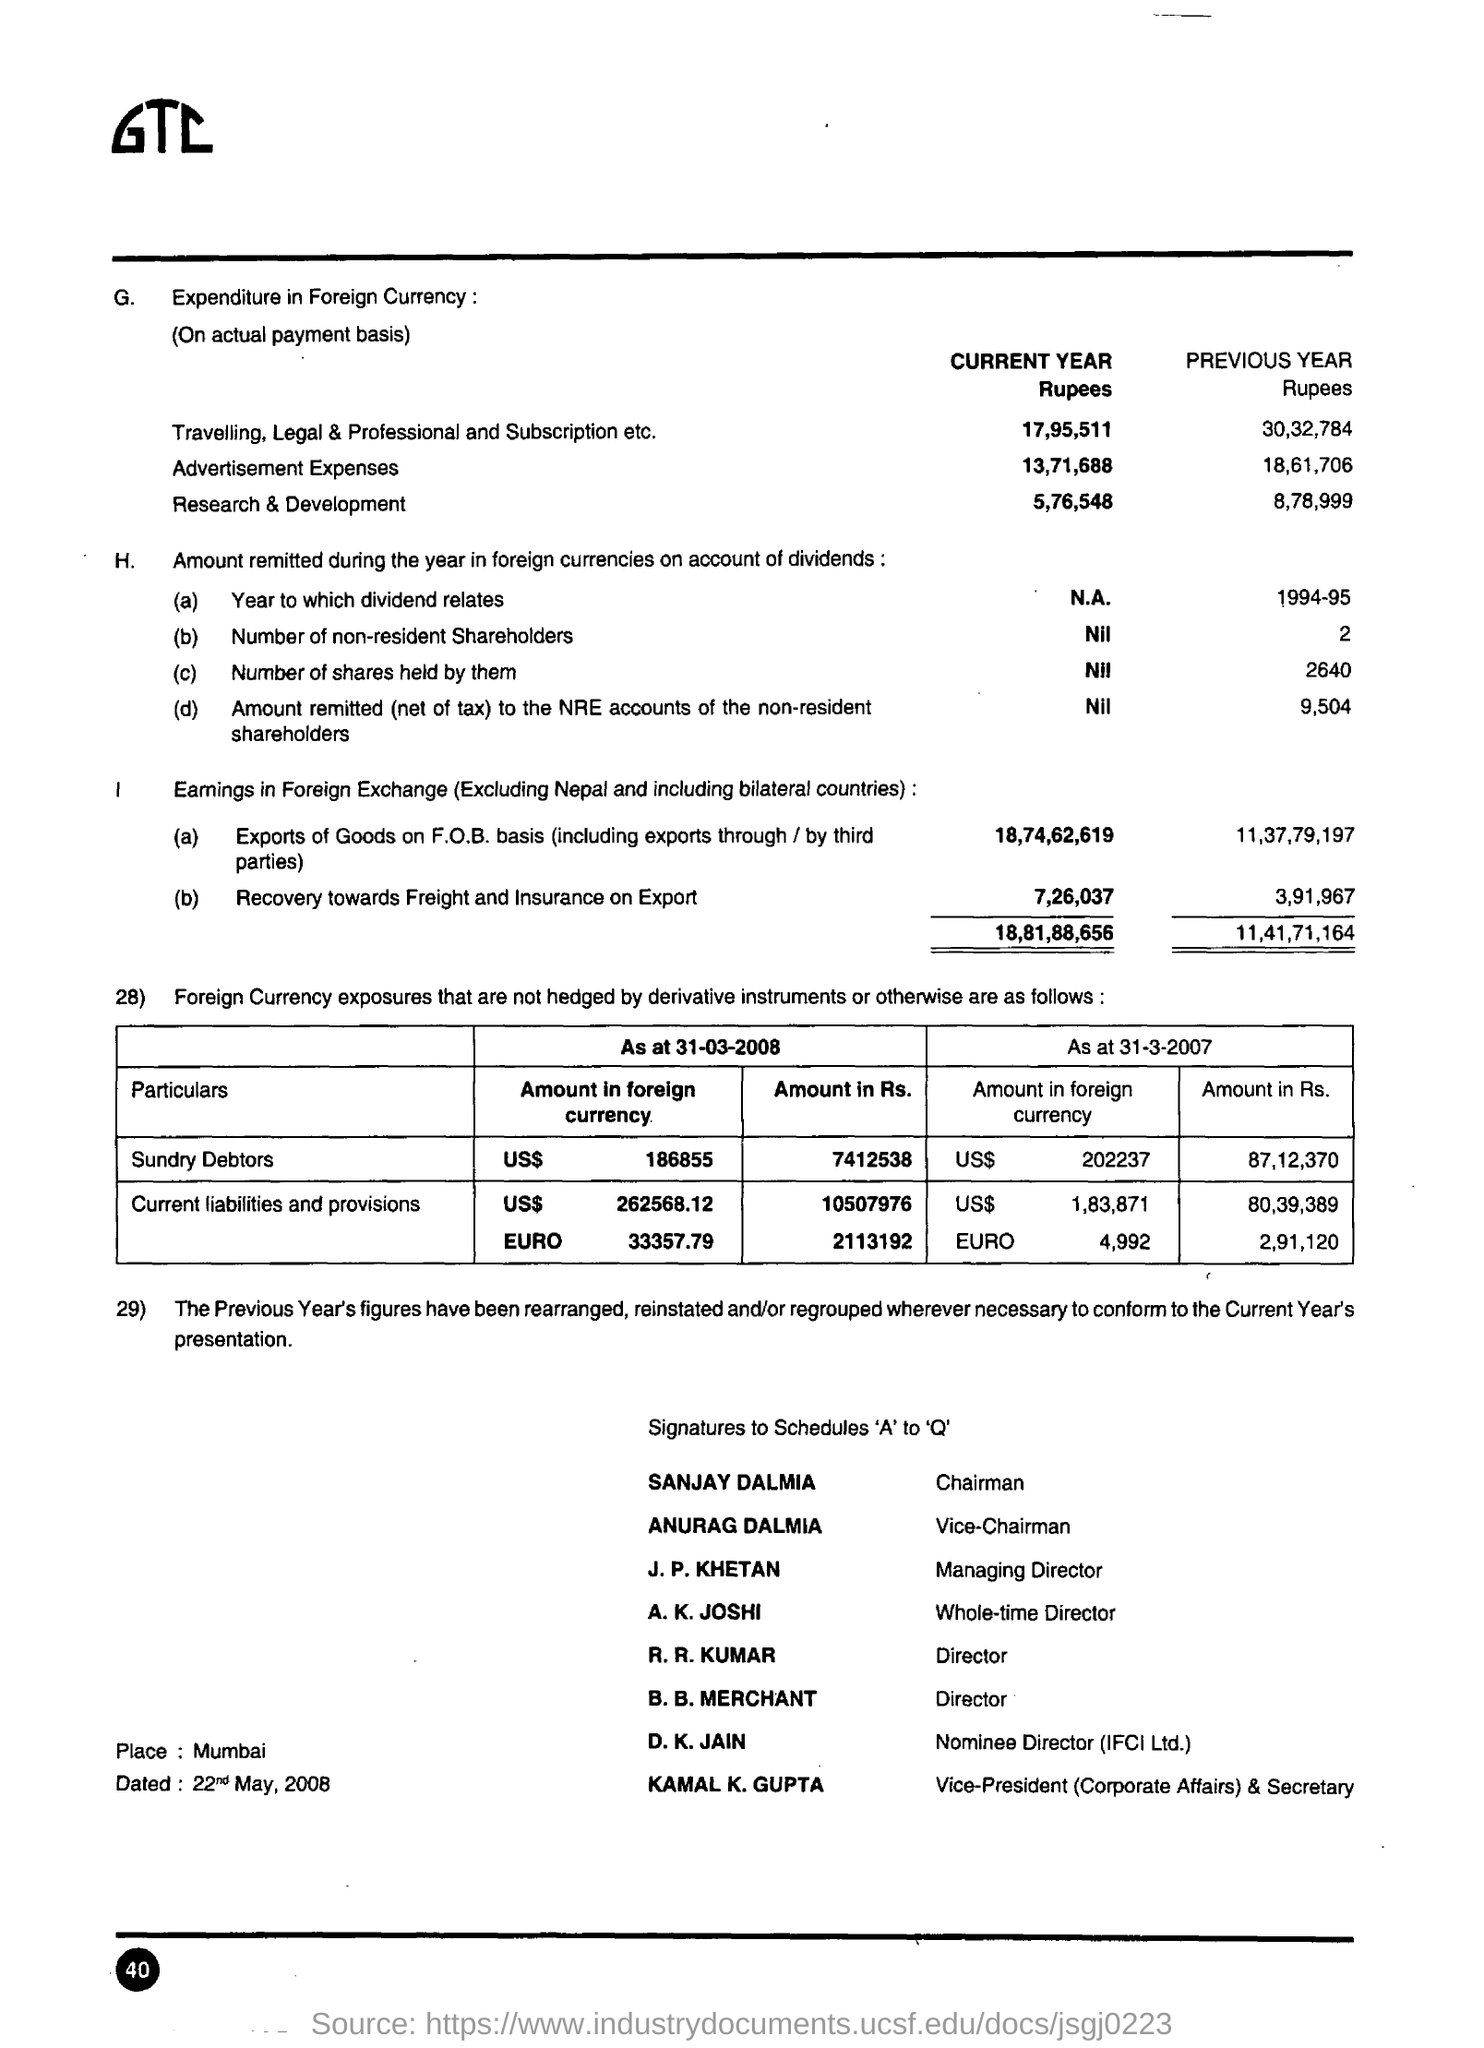Point out several critical features in this image. Anurag Dalmia is the vice chairman. Sanjay Dalmia is the chairman. The recovery of freight and insurance for the previous year was 3,91,967 rupees. The place mentioned is Mumbai. The recovery for freight and insurance on export for the current year is approximately 7,26,037 rupees. 